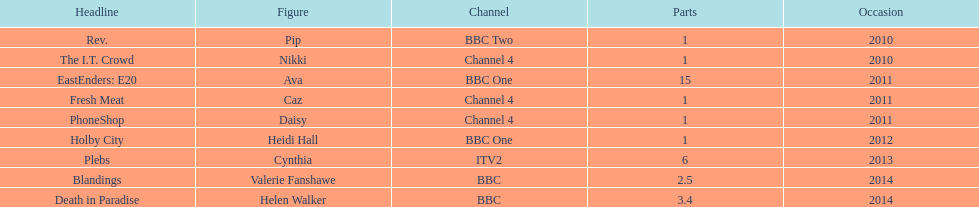Which broadcaster hosted 3 titles but they had only 1 episode? Channel 4. Would you mind parsing the complete table? {'header': ['Headline', 'Figure', 'Channel', 'Parts', 'Occasion'], 'rows': [['Rev.', 'Pip', 'BBC Two', '1', '2010'], ['The I.T. Crowd', 'Nikki', 'Channel 4', '1', '2010'], ['EastEnders: E20', 'Ava', 'BBC One', '15', '2011'], ['Fresh Meat', 'Caz', 'Channel 4', '1', '2011'], ['PhoneShop', 'Daisy', 'Channel 4', '1', '2011'], ['Holby City', 'Heidi Hall', 'BBC One', '1', '2012'], ['Plebs', 'Cynthia', 'ITV2', '6', '2013'], ['Blandings', 'Valerie Fanshawe', 'BBC', '2.5', '2014'], ['Death in Paradise', 'Helen Walker', 'BBC', '3.4', '2014']]} 